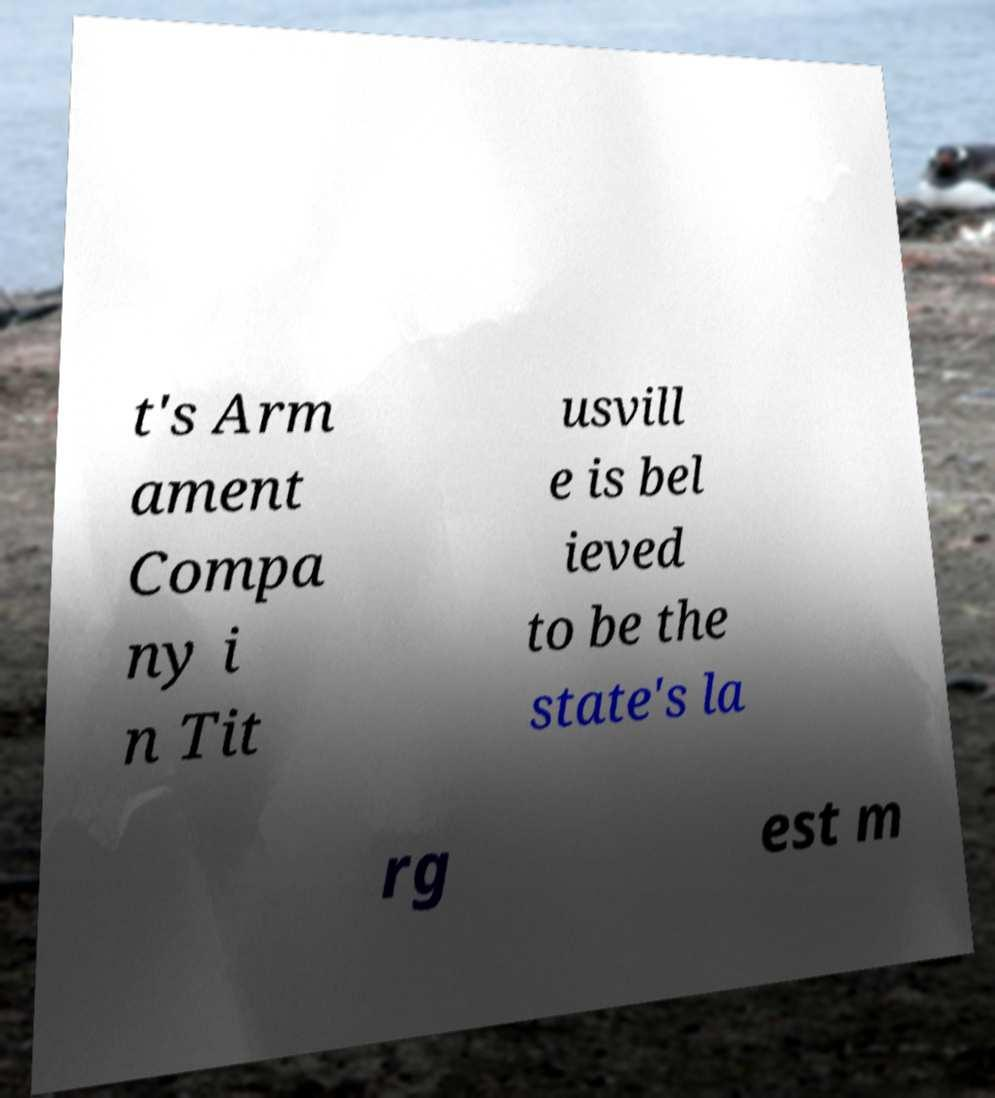I need the written content from this picture converted into text. Can you do that? t's Arm ament Compa ny i n Tit usvill e is bel ieved to be the state's la rg est m 